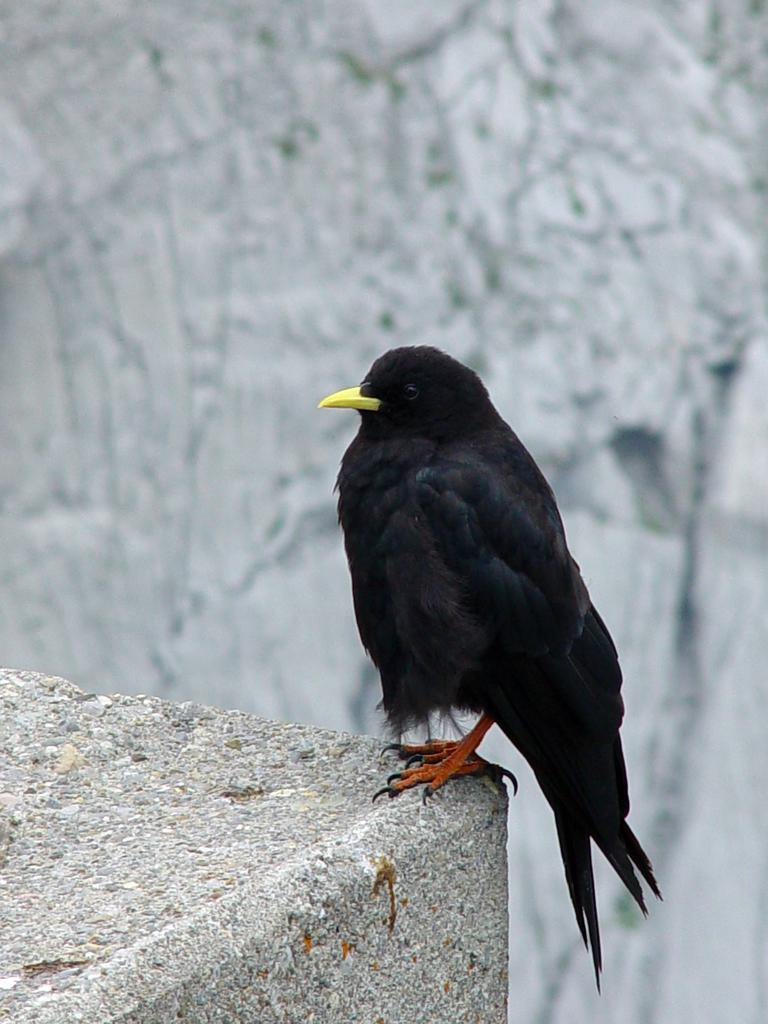What is the main subject in the foreground of the image? There is a bird in the foreground of the image. Where is the bird located in relation to the stone surface? The bird is on the edge of a stone surface. What can be seen in the background of the image? There is a rock visible in the background of the image. What is the writer's opinion on the bird's behavior in the image? There is no writer present in the image, and therefore no opinion can be attributed to them. 